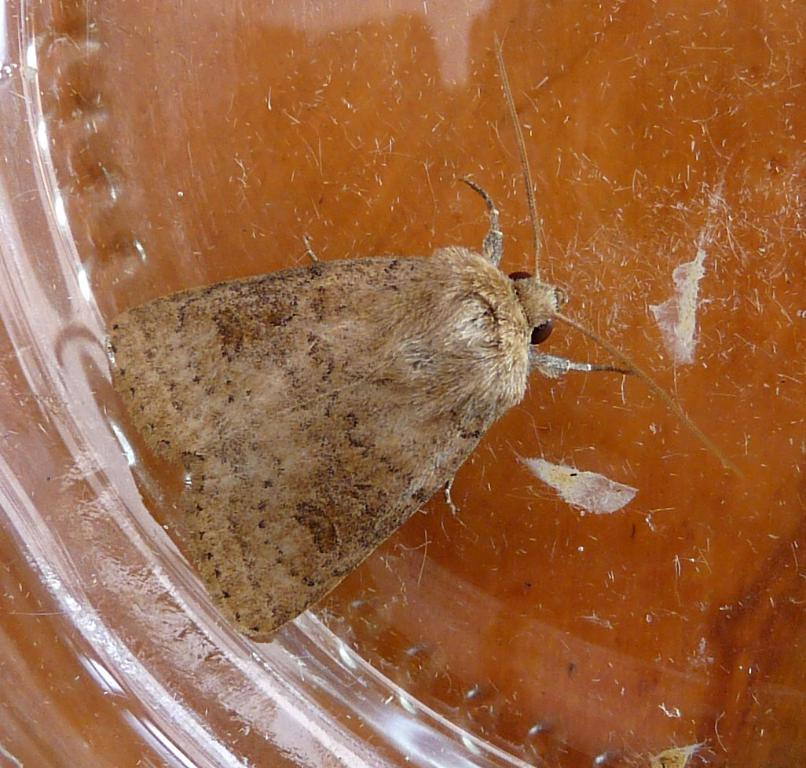What is the main subject of the picture? The main subject of the picture is an insect. Where is the insect located in the picture? The insect is in the middle of the picture. What color is the insect? The insect is brown in color. What type of hammer can be seen in the picture? There is no hammer present in the picture; it features an insect. How many times does the ground twist in the picture? There is no ground or twisting action present in the picture; it features an insect. 